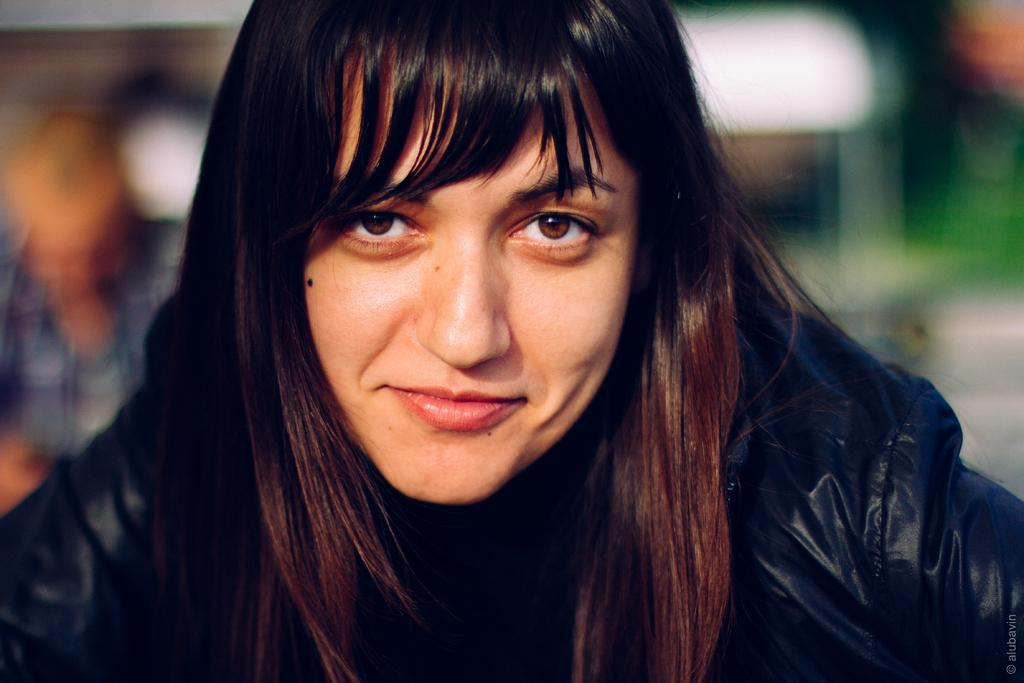Who is the main subject in the image? There is a woman in the image. What is the woman wearing? The woman is wearing a black dress. Can you describe the background of the image? The background of the image is blurred. How many feet does the snail have in the image? There is no snail present in the image. 